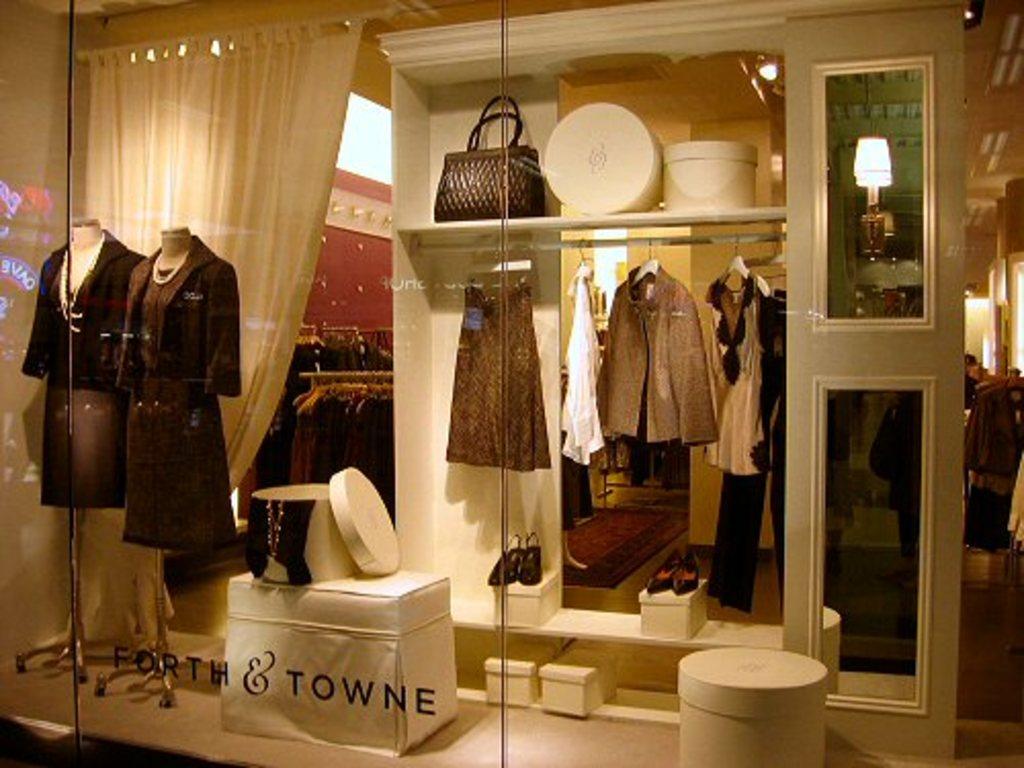Forth and what?
Your response must be concise. Towne. 